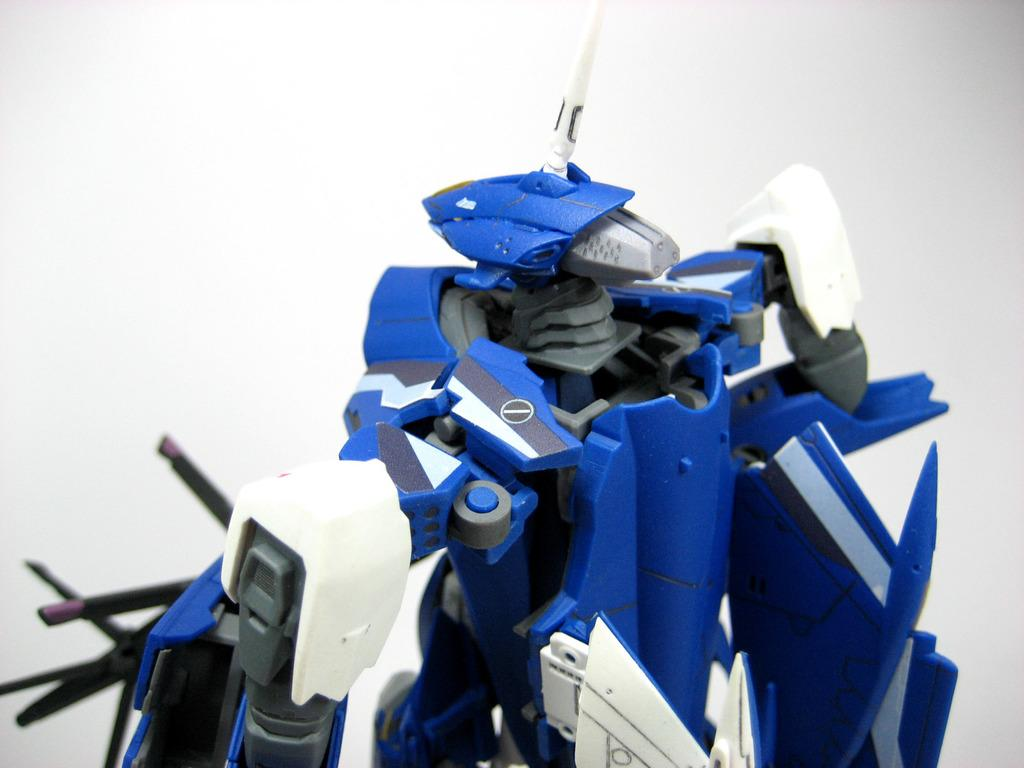What can be seen in the image? There is an object in the image. What color is the background of the image? The background of the image is white. Is there a collar visible on the object in the image? There is no collar present in the image, as the object is not a living being that would typically wear a collar. 